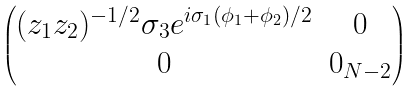Convert formula to latex. <formula><loc_0><loc_0><loc_500><loc_500>\begin{pmatrix} ( z _ { 1 } z _ { 2 } ) ^ { - 1 / 2 } \sigma _ { 3 } e ^ { i \sigma _ { 1 } ( \phi _ { 1 } + \phi _ { 2 } ) / 2 } & 0 \\ 0 & 0 _ { N - 2 } \end{pmatrix}</formula> 